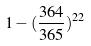<formula> <loc_0><loc_0><loc_500><loc_500>1 - ( \frac { 3 6 4 } { 3 6 5 } ) ^ { 2 2 }</formula> 